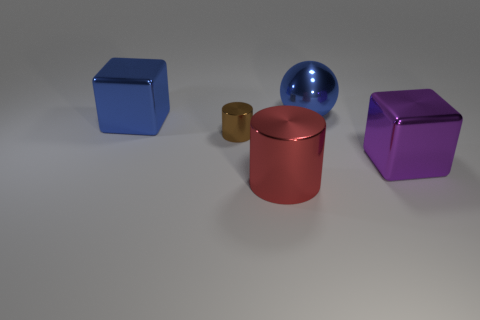Does the sphere have the same color as the tiny metallic cylinder?
Provide a succinct answer. No. Is the number of big shiny blocks to the left of the tiny brown metallic object less than the number of large red blocks?
Offer a terse response. No. What is the material of the big object that is the same color as the sphere?
Provide a succinct answer. Metal. Are the large blue cube and the purple block made of the same material?
Your response must be concise. Yes. How many other things are the same material as the tiny brown object?
Your answer should be very brief. 4. What is the color of the other cube that is made of the same material as the big purple block?
Your answer should be compact. Blue. There is a large purple thing; what shape is it?
Provide a succinct answer. Cube. There is a blue thing behind the big blue block; what material is it?
Your answer should be compact. Metal. Is there a large cylinder that has the same color as the shiny sphere?
Give a very brief answer. No. What is the shape of the red thing that is the same size as the metal sphere?
Keep it short and to the point. Cylinder. 